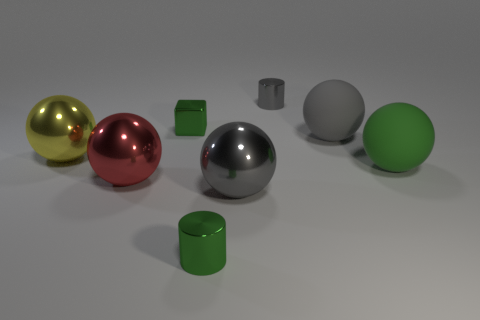Subtract all red balls. How many balls are left? 4 Subtract all green spheres. How many spheres are left? 4 Subtract all blue spheres. Subtract all purple cubes. How many spheres are left? 5 Add 2 big green metallic cubes. How many objects exist? 10 Subtract all cylinders. How many objects are left? 6 Subtract all big cubes. Subtract all gray metallic objects. How many objects are left? 6 Add 3 green rubber spheres. How many green rubber spheres are left? 4 Add 8 large red shiny balls. How many large red shiny balls exist? 9 Subtract 1 green balls. How many objects are left? 7 